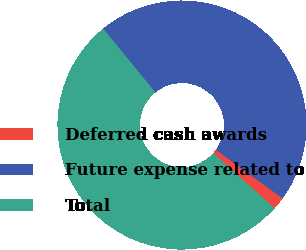Convert chart to OTSL. <chart><loc_0><loc_0><loc_500><loc_500><pie_chart><fcel>Deferred cash awards<fcel>Future expense related to<fcel>Total<nl><fcel>1.63%<fcel>45.93%<fcel>52.44%<nl></chart> 